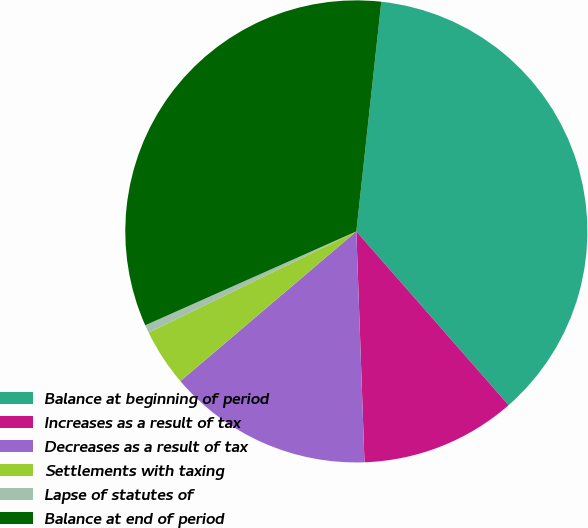Convert chart. <chart><loc_0><loc_0><loc_500><loc_500><pie_chart><fcel>Balance at beginning of period<fcel>Increases as a result of tax<fcel>Decreases as a result of tax<fcel>Settlements with taxing<fcel>Lapse of statutes of<fcel>Balance at end of period<nl><fcel>36.82%<fcel>10.89%<fcel>14.34%<fcel>4.0%<fcel>0.56%<fcel>33.38%<nl></chart> 